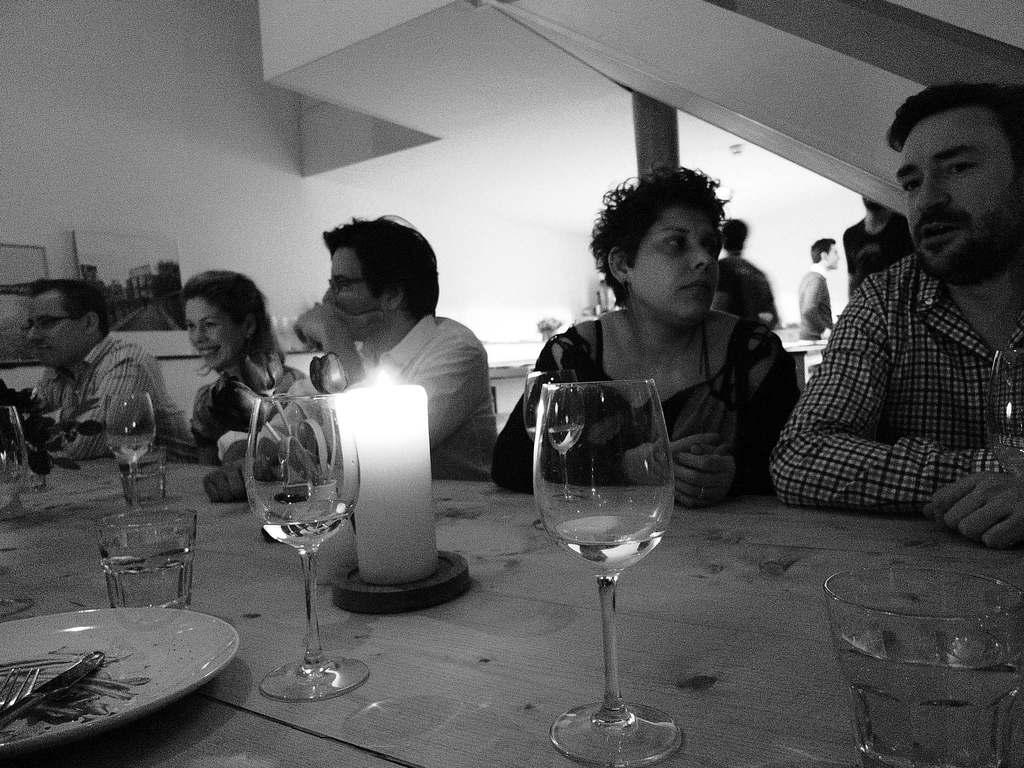What are the people in the image doing? The people in the image are sitting in front of the table. What can be seen on the table? There is a glass, a candle, a plate, and a fork on the table. What is visible at the back side of the image? There is a wall visible at the back side of the image. How many things are hanging from the hook in the image? There is no hook present in the image. 